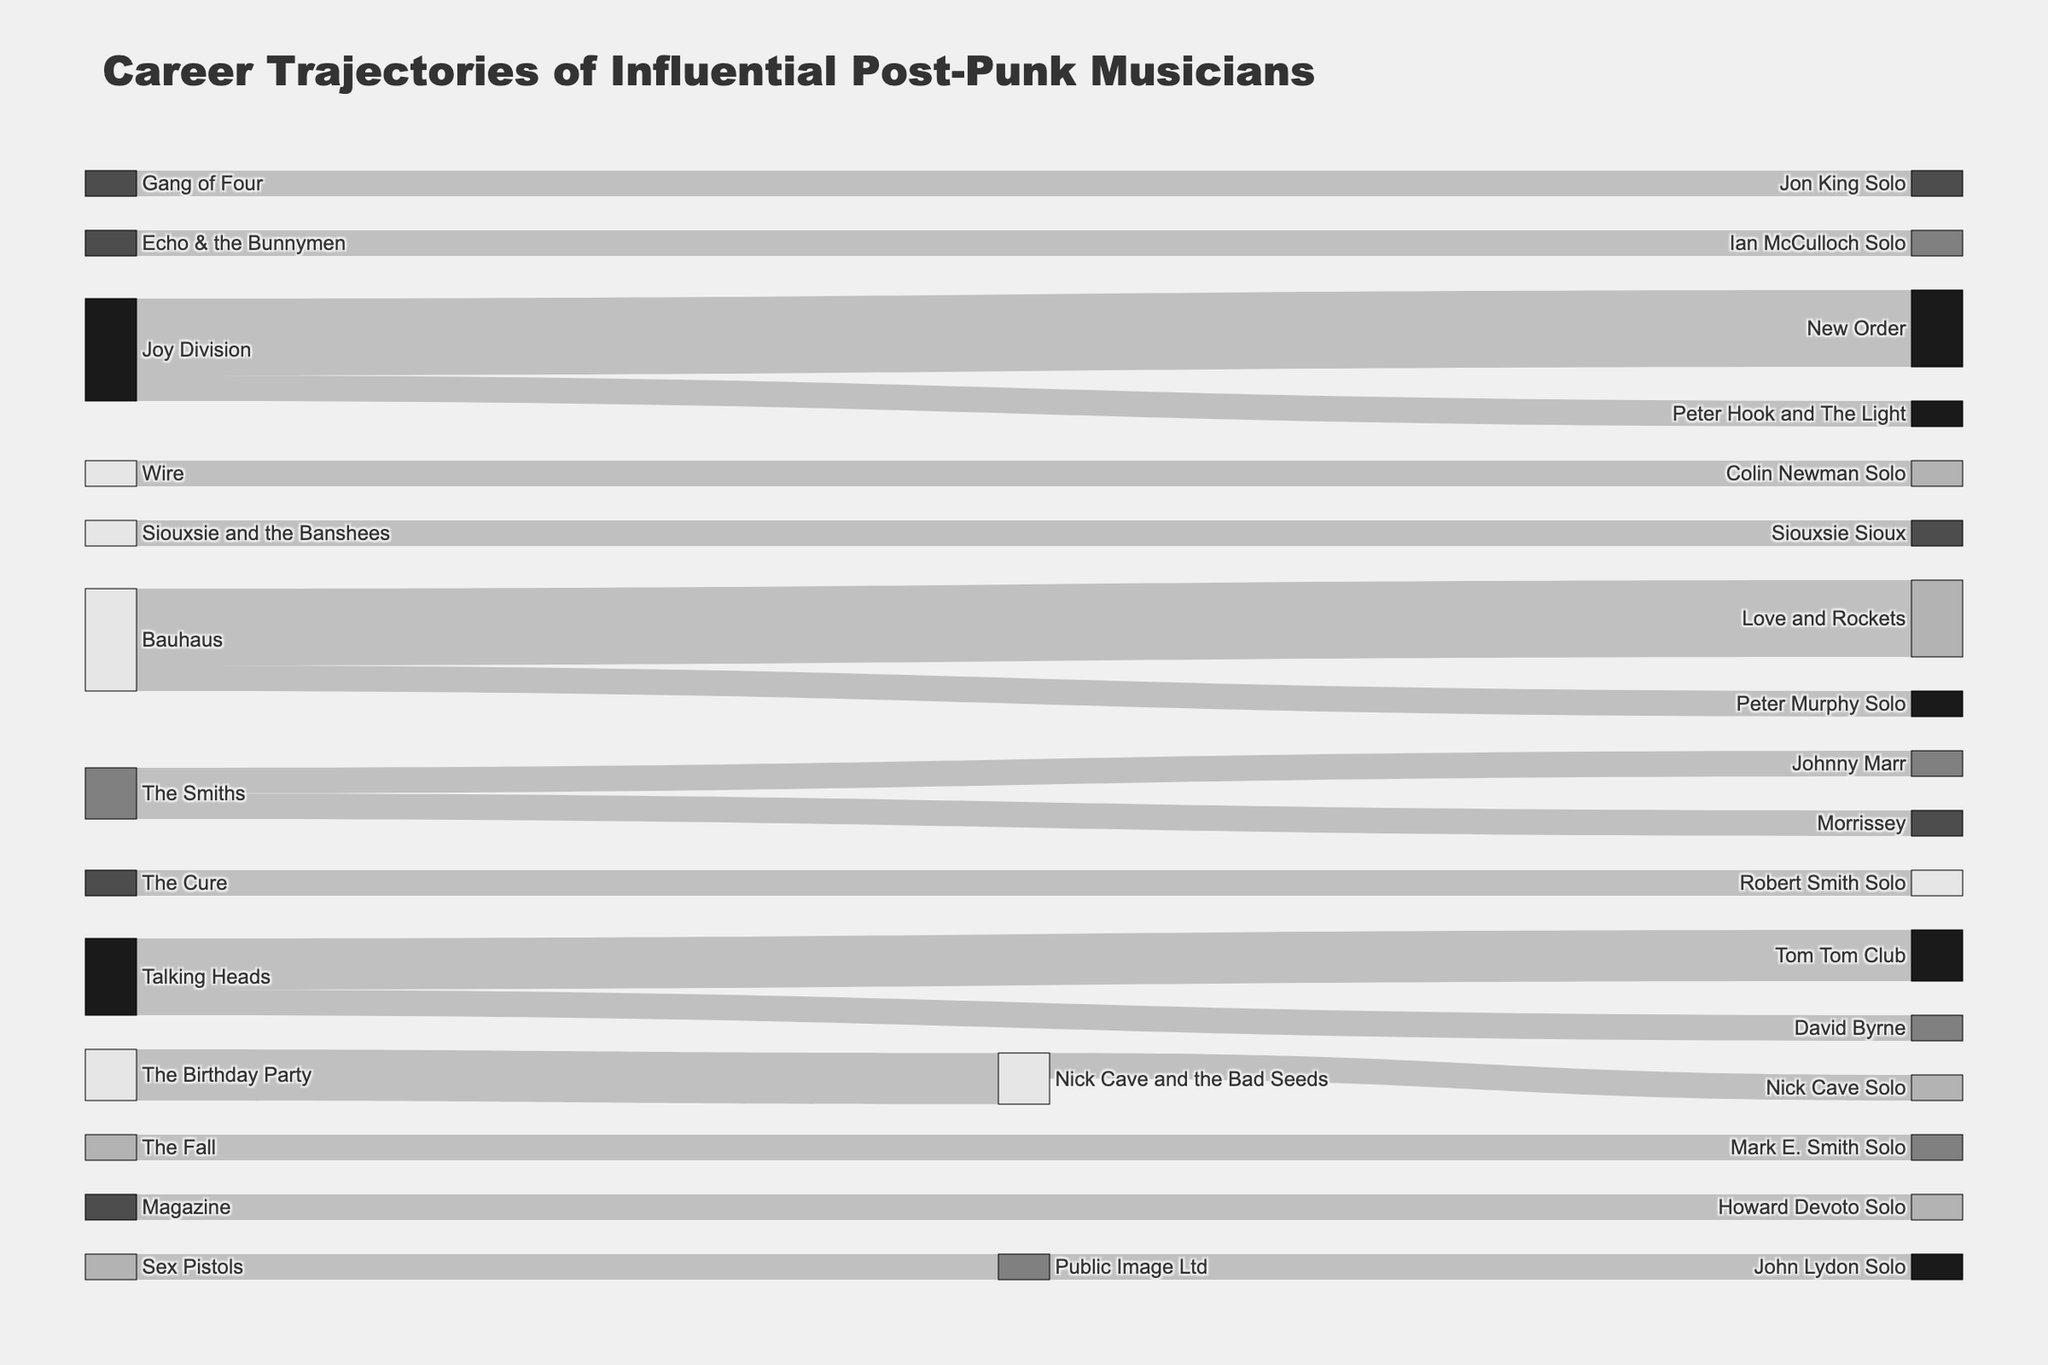what's the title of the Sankey diagram? The title of the diagram is usually placed at the top and describes the main topic of the visualization. It reads "Career Trajectories of Influential Post-Punk Musicians".
Answer: Career Trajectories of Influential Post-Punk Musicians which transition has the highest value in the diagram? The transition with the highest value would have the thickest line between nodes. By visually inspecting the diagram, the transition from Bauhaus to Love and Rockets has the highest value.
Answer: Bauhaus to Love and Rockets how many musicians moved from Joy Division to other bands or solo projects? We need to count the number of arrows coming out from Joy Division. According to the diagram, Joy Division has transitions to New Order (3) and Peter Hook and The Light (1). Summing these gives 3 + 1.
Answer: 4 what's the relationship between Sex Pistols and John Lydon Solo? To find the relationship, trace the path from Sex Pistols to John Lydon Solo. According to the diagram, there is an intermediate step through Public Image Ltd before reaching John Lydon Solo.
Answer: Sex Pistols -> Public Image Ltd -> John Lydon Solo which artist has a solo career linked to The Smiths? Look for the node labeled "The Smiths" and find the nodes it is connected to. It's linked to Morrissey (Solo) and Johnny Marr (Solo).
Answer: Morrissey and Johnny Marr how many bands are connected to New Order? Find the New Order node and look for all the arrows pointing towards it. There is only one arrow from Joy Division.
Answer: 1 is there any musician who has transitioned to more than one solo career? We need to find nodes representing musicians and check the connections labeled "Solo". Both Peter Hook and The Light (Peter Hook from Joy Division) and Love and Rockets (members from Bauhaus) are bands, not solo careers. Thus, no musician in this dataset transitioned to more than one solo career.
Answer: No which band has the most members branching out into solo careers? Look for the band node with the most connections to solo career nodes. The Smiths have two separate solo career transitions: Morrissey and Johnny Marr.
Answer: The Smiths which band did Nick Cave move to after The Birthday Party? Check the direct transition from The Birthday Party node. Nick Cave and the Bad Seeds is the next band for Nick Cave.
Answer: Nick Cave and the Bad Seeds how many connections does Public Image Ltd have in total? Count both incoming and outgoing arrows for the Public Image Ltd node. It has one incoming from Sex Pistols and one outgoing to John Lydon Solo.
Answer: 2 